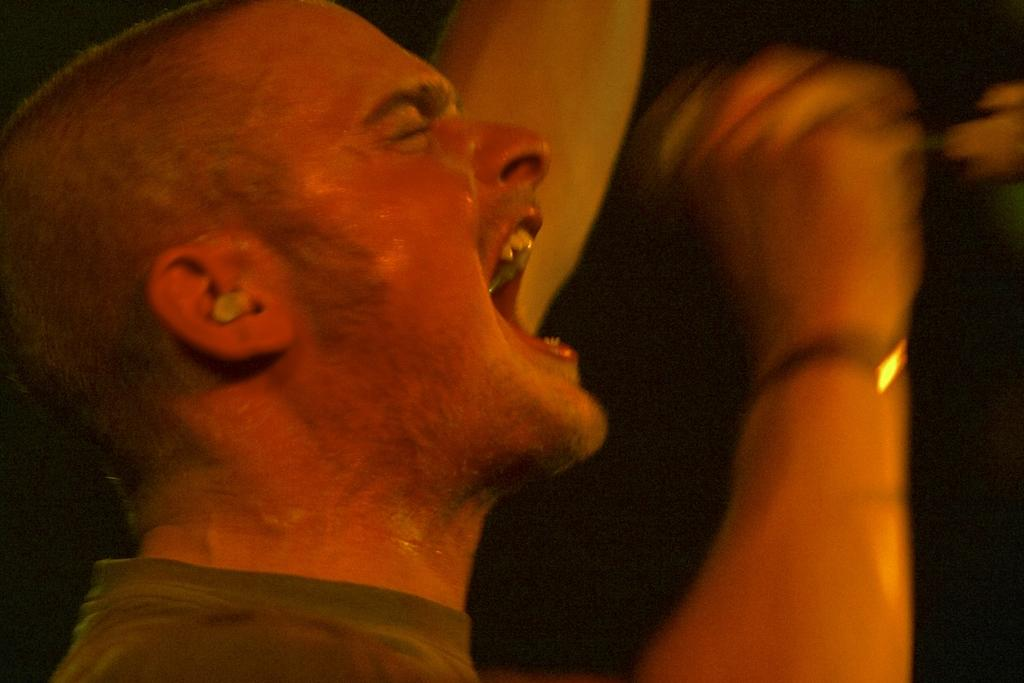What is the main subject in the foreground of the image? There is a person in the foreground of the image. What is the person holding in his hand? The person is holding a mic in his hand. What type of silk fabric is draped over the family in the bedroom in the image? There is no reference to silk, family, or a bedroom in the image; it only features a person holding a mic. 